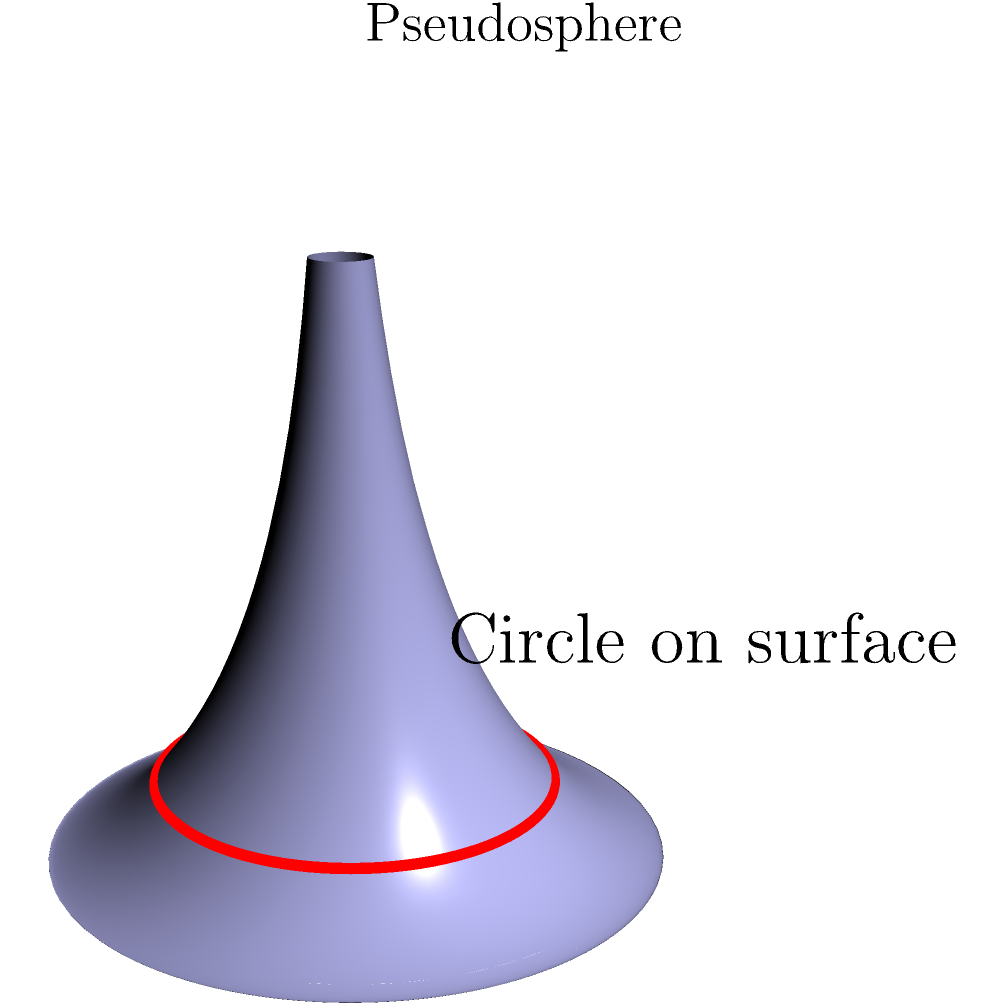As a former prima ballerina, you understand the importance of precision and spatial awareness. Consider a circle drawn on the surface of a pseudosphere, as shown in the diagram. If the circle has a radius of 1 unit when measured along the surface, what is the area of this circle? Assume the pseudosphere has a constant negative curvature $K = -\frac{1}{a^2}$, where $a$ is the radius of the pseudosphere's waist. To solve this problem, we'll follow these steps:

1) First, recall that for a surface with constant negative curvature $K$, the area of a circle with radius $r$ is given by:

   $$A = \frac{4\pi}{|K|} \sinh^2(\frac{\sqrt{|K|}r}{2})$$

2) We're given that $K = -\frac{1}{a^2}$, so $|K| = \frac{1}{a^2}$

3) Substituting this into our area formula:

   $$A = 4\pi a^2 \sinh^2(\frac{r}{2a})$$

4) We're told the radius $r = 1$, so our final formula is:

   $$A = 4\pi a^2 \sinh^2(\frac{1}{2a})$$

5) This is our final answer. We can't simplify further without knowing the value of $a$.

6) Note that this area is larger than the area of a circle with radius 1 on a flat plane ($\pi$), which aligns with the negative curvature of the pseudosphere causing distances to expand as you move away from a point.
Answer: $4\pi a^2 \sinh^2(\frac{1}{2a})$ 